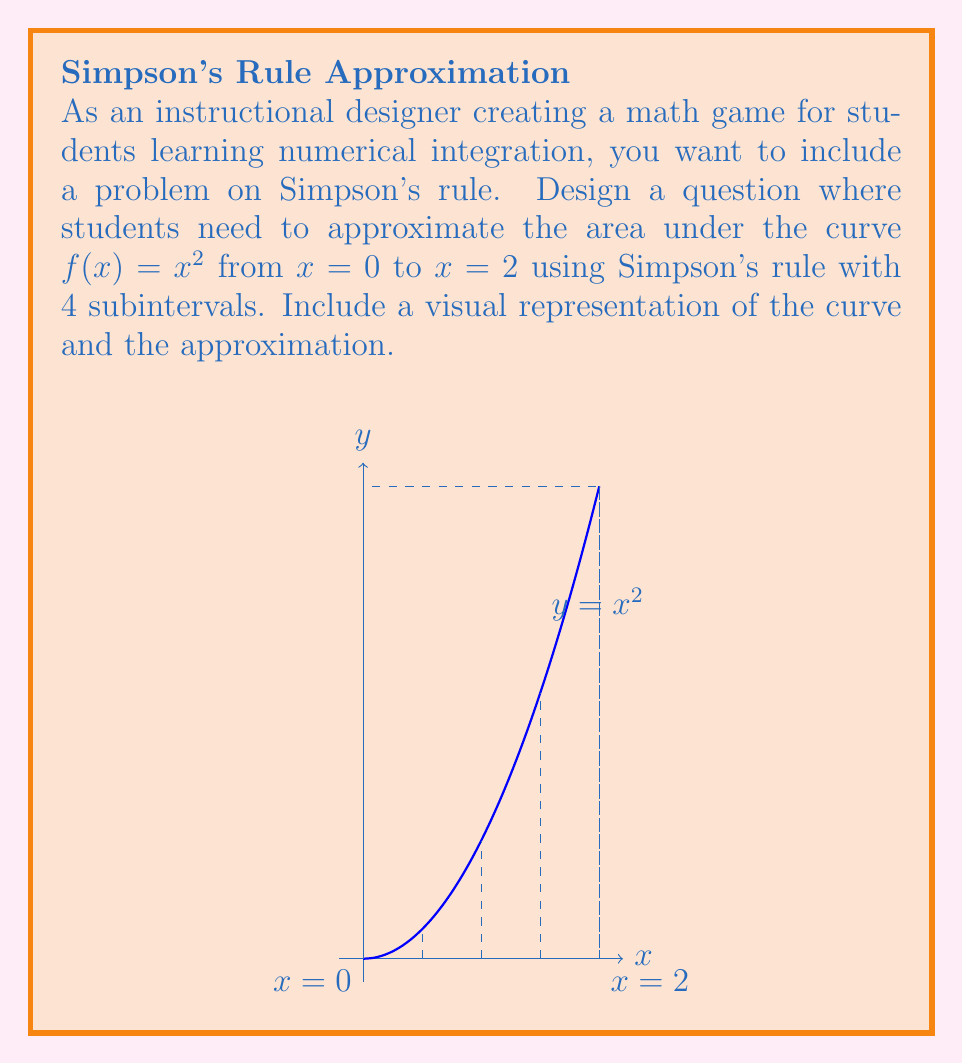Teach me how to tackle this problem. To approximate the integral using Simpson's rule with 4 subintervals:

1) The formula for Simpson's rule is:

   $$\int_a^b f(x)dx \approx \frac{h}{3}[f(x_0) + 4f(x_1) + 2f(x_2) + 4f(x_3) + f(x_4)]$$

   where $h = \frac{b-a}{n}$, $n$ is the number of subintervals, and $x_i = a + ih$.

2) Here, $a=0$, $b=2$, $n=4$, so $h = \frac{2-0}{4} = 0.5$

3) Calculate the $x$ values:
   $x_0 = 0$, $x_1 = 0.5$, $x_2 = 1$, $x_3 = 1.5$, $x_4 = 2$

4) Calculate $f(x)$ for each $x$ value:
   $f(0) = 0^2 = 0$
   $f(0.5) = 0.5^2 = 0.25$
   $f(1) = 1^2 = 1$
   $f(1.5) = 1.5^2 = 2.25$
   $f(2) = 2^2 = 4$

5) Apply Simpson's rule:

   $$\frac{0.5}{3}[0 + 4(0.25) + 2(1) + 4(2.25) + 4]$$

6) Simplify:

   $$\frac{0.5}{3}[0 + 1 + 2 + 9 + 4] = \frac{0.5}{3}(16) = \frac{8}{3} \approx 2.6667$$

The actual value of the integral is $\frac{8}{3}$, so Simpson's rule gives the exact answer in this case.
Answer: $\frac{8}{3}$ 